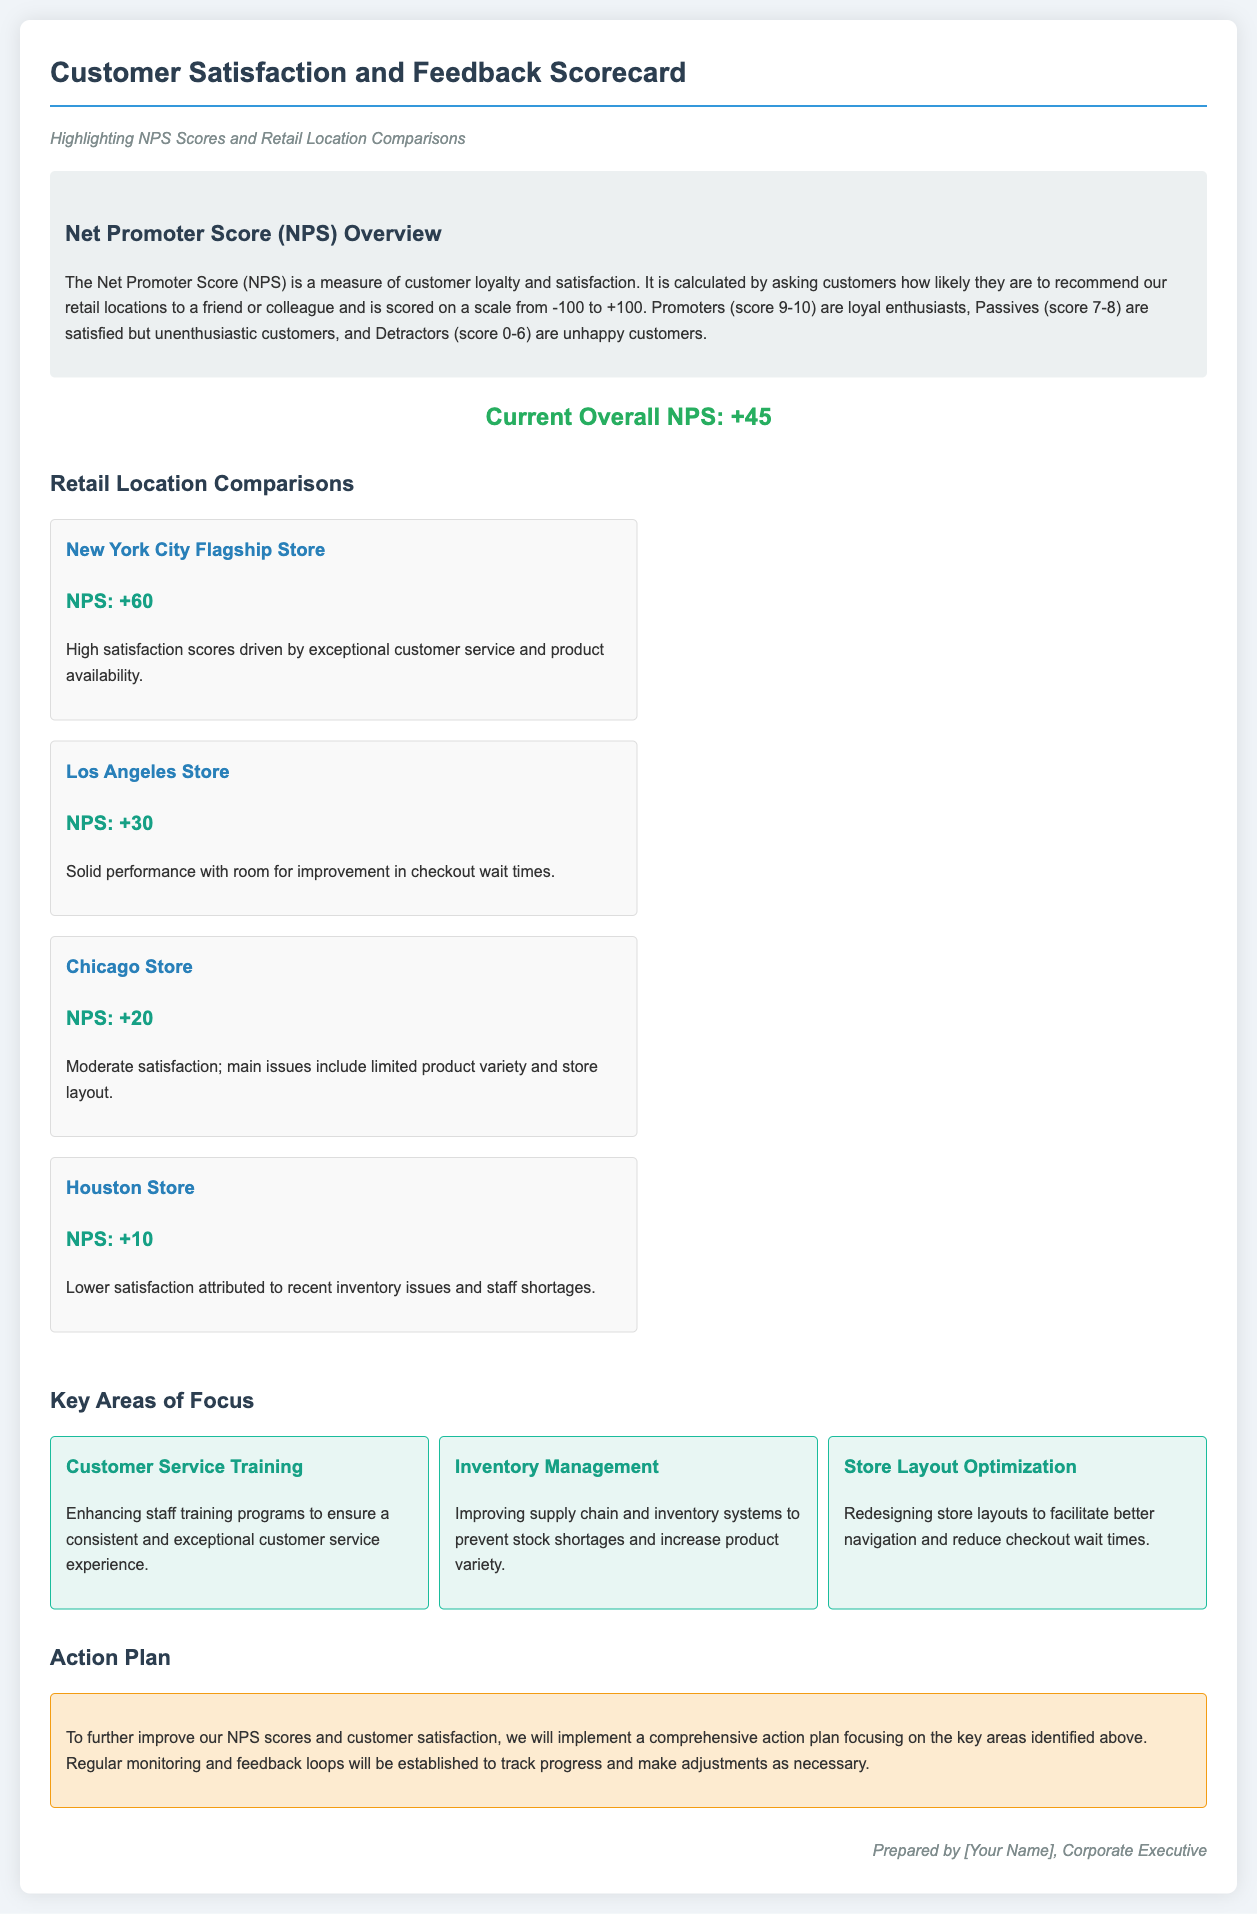What is the current overall NPS? The current overall NPS is clearly stated in the document under the "Current Overall NPS" section.
Answer: +45 What is the NPS score for the New York City Flagship Store? The NPS score for the New York City Flagship Store is mentioned in the location comparison section.
Answer: +60 Which location has the lowest NPS score? The location with the lowest NPS score is identified in the retail location comparisons section.
Answer: Houston Store What are the main issues affecting customer satisfaction at the Houston Store? The document lists specific issues in the description of the Houston Store, highlighting the factors affecting customer satisfaction.
Answer: Inventory issues and staff shortages What area of focus is suggested to enhance customer service? The document outlines key focus areas, specifically mentioning which area addresses customer service improvement.
Answer: Customer Service Training What is the NPS score of the Chicago Store? The NPS score for the Chicago Store is provided in the location comparison section.
Answer: +20 How many key areas of focus are identified in the document? The document specifies how many focus areas are detailed for improvement.
Answer: Three What is the main goal of the action plan presented? The action plan outlines its purpose regarding customer satisfaction and NPS improvement, which can be found at the end of the document.
Answer: Improve NPS scores and customer satisfaction 